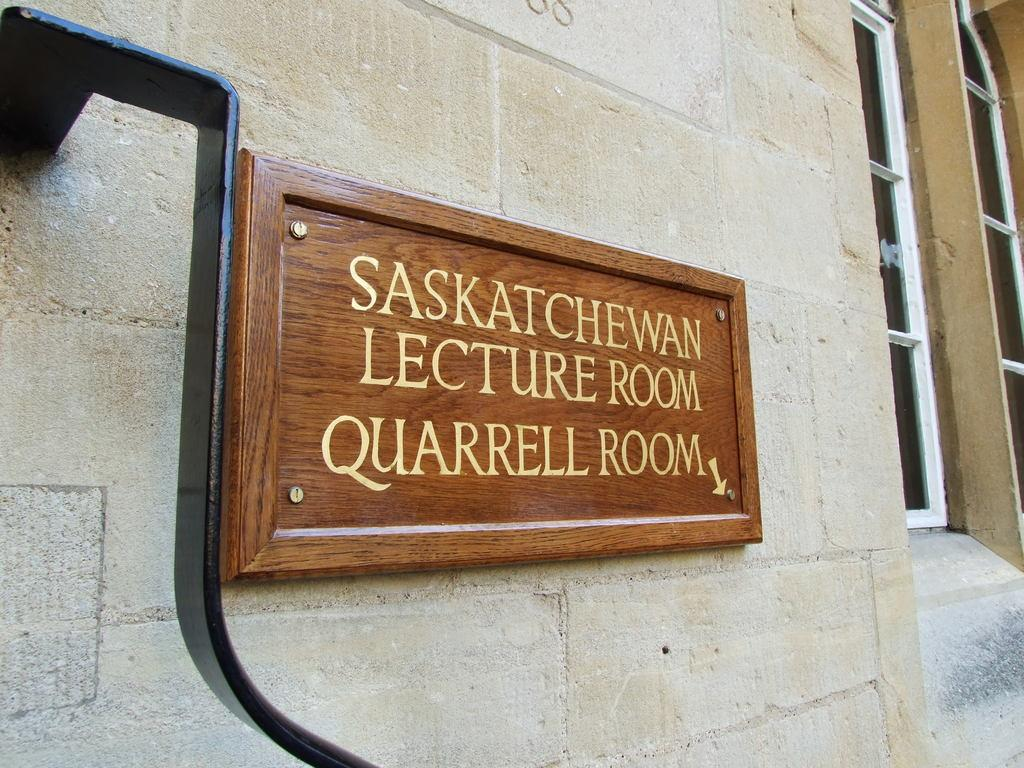What is attached to the wall in the image? There is a name board attached to the wall in the image. What feature does the name board have? The name board has windows. What else can be seen attached to the wall on the left side in the image? There is a metal rod attached to the wall on the left side in the image. What type of adjustment can be seen on the name board in the image? There is no adjustment visible on the name board in the image. Can you tell me the size of the spot on the name board in the image? There is no spot present on the name board in the image. 